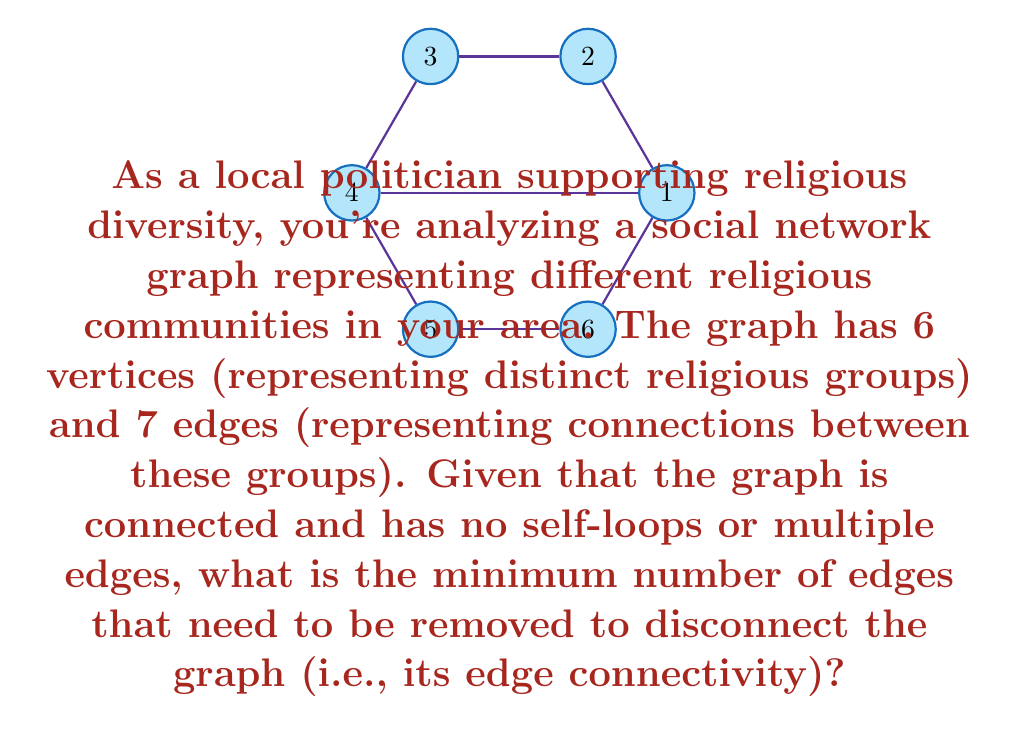Can you solve this math problem? To determine the edge connectivity of this graph, we need to find the minimum number of edges whose removal would disconnect the graph. Let's approach this step-by-step:

1) First, recall that for any graph G, its edge connectivity $\lambda(G)$ is always less than or equal to its minimum degree $\delta(G)$. That is, $\lambda(G) \leq \delta(G)$.

2) In this graph, we can see that each vertex has at least 2 edges connected to it. So, the minimum degree $\delta(G) = 2$.

3) This means that the edge connectivity $\lambda(G)$ is at most 2.

4) Now, let's consider if removing just one edge could disconnect the graph. If we remove any single edge, the graph remains connected due to the circular structure and the diagonal edge.

5) Therefore, we need to remove at least 2 edges to disconnect the graph.

6) We can verify this by finding a cut set of size 2. For example, removing the edges (1,2) and (1,6) would disconnect vertex 1 from the rest of the graph.

7) Since we've found a cut set of size 2, and we know that $\lambda(G) \leq 2$, we can conclude that the edge connectivity of this graph is exactly 2.

This means that as a local politician, you would need to sever at least two connections between religious communities to isolate one community from the others in this network.
Answer: 2 